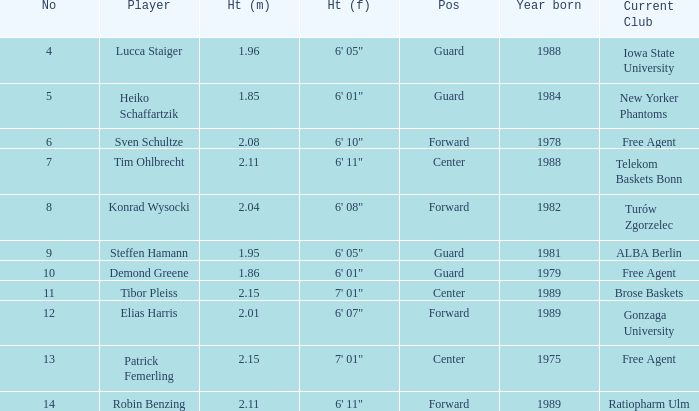Name the player that is 1.85 m Heiko Schaffartzik. 